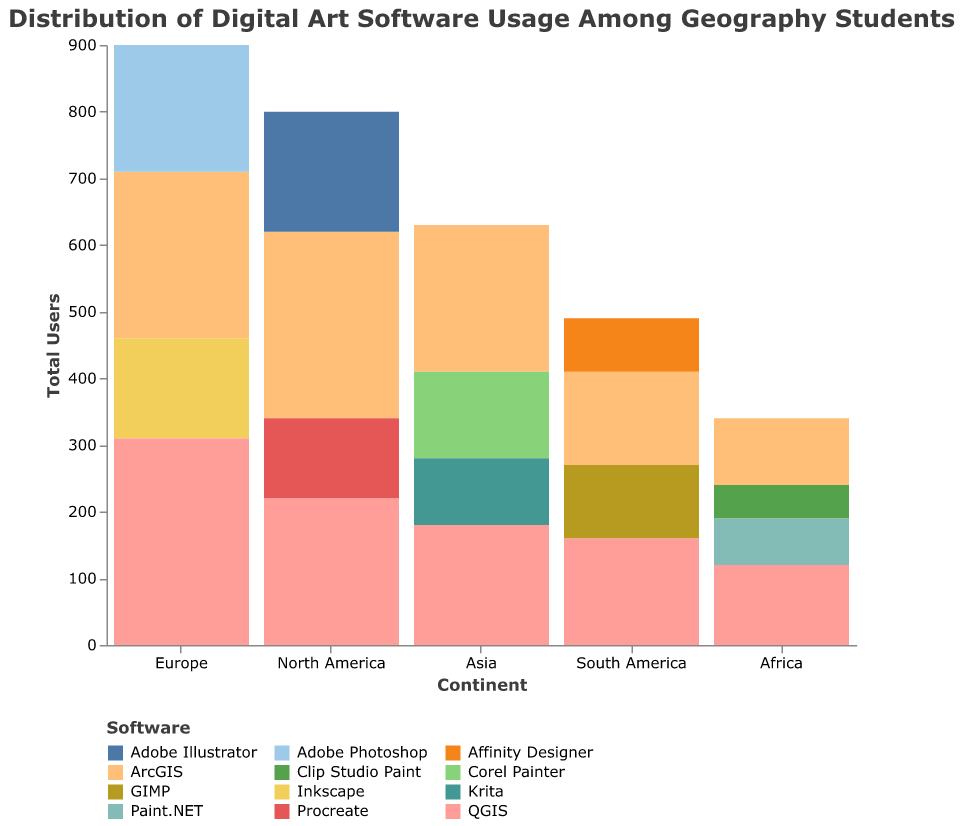Which continent has the highest total number of users for digital art software? The bar height on the y-axis represents the total number of users. The continent with the highest bar is Europe.
Answer: Europe How many users are there for ArcGIS in Asia? Find the segment corresponding to ArcGIS within the Asia bar. The value for ArcGIS in Asia is 220.
Answer: 220 Which software has the most users among geography students in Africa? Compare the height of the segments within the Africa bar. The segment for QGIS is the highest.
Answer: QGIS What is the total number of users for Adobe products (Illustrator and Photoshop) in Europe? Identify the segments for Adobe Illustrator and Adobe Photoshop within the Europe bar and sum their values (190 for Photoshop + 0 for Illustrator = 190).
Answer: 190 Which continent has the smallest number of users for QGIS? Compare the QGIS segments across all continent bars. The smallest segment is in Africa, which has 120 users.
Answer: Africa What is the difference in the number of users between ArcGIS and QGIS in South America? Identify the segments for ArcGIS and QGIS in the South America bar and subtract their values (160 for QGIS - 140 for ArcGIS = 20).
Answer: 20 On which continent is Procreate used? Identify the segment representing Procreate within all bars. Procreate appears in the North America bar only.
Answer: North America How many total users are there for digital art software in North America? Sum all the segments' heights within the North America bar: (280 + 220 + 180 + 120).
Answer: 800 Which continent has more users for the software Inkscape, Europe or Asia? Compare the Inkscape segment only found in the Europe bar. It doesn't appear in Asia.
Answer: Europe Is there any software listed that is used exclusively on one continent? Look at each segment and identify if any software is unique to a continent. Clip Studio Paint is only in Africa, Affinity Designer in South America, etc.
Answer: Yes 